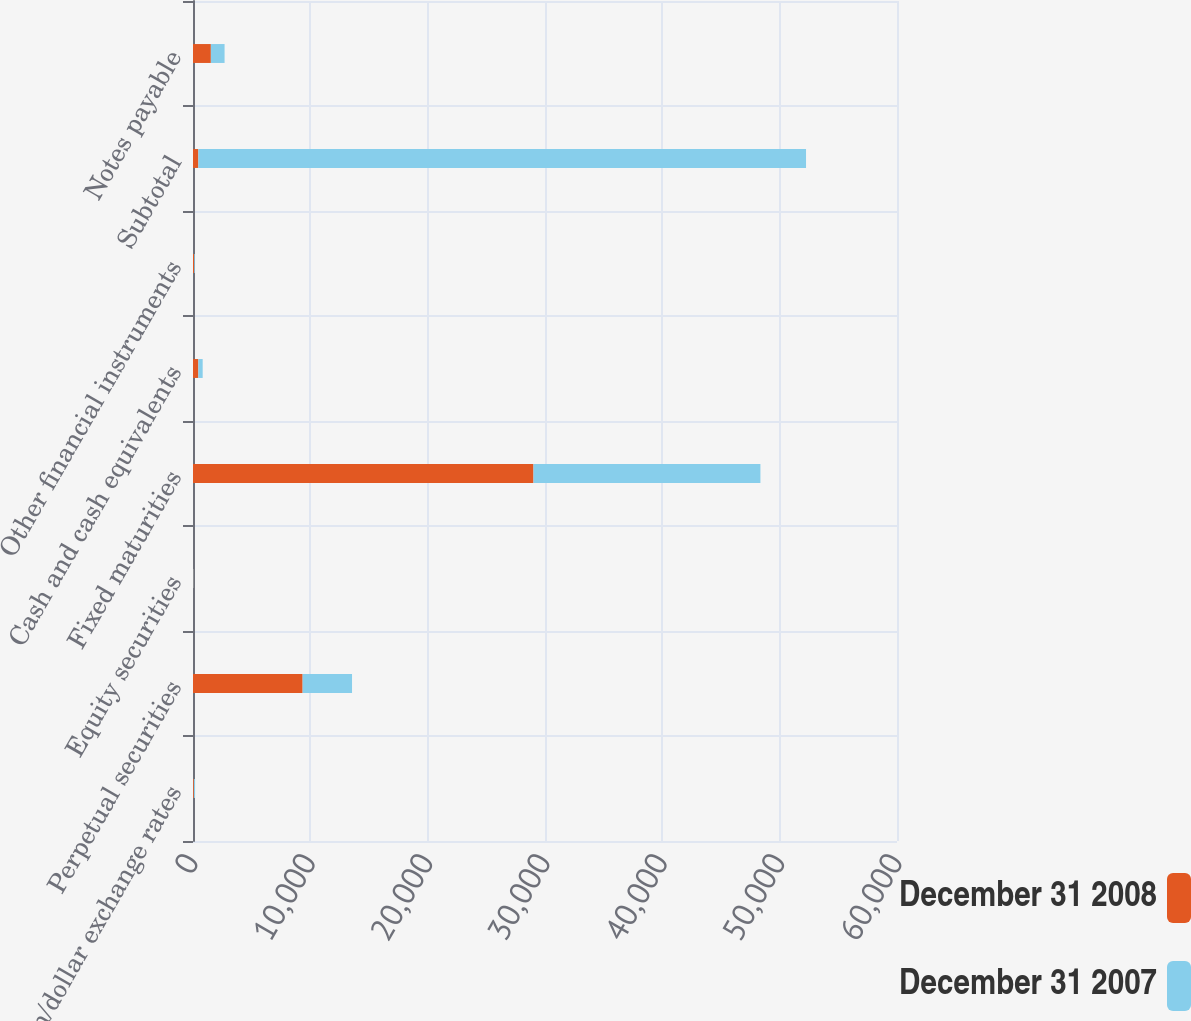Convert chart to OTSL. <chart><loc_0><loc_0><loc_500><loc_500><stacked_bar_chart><ecel><fcel>Yen/dollar exchange rates<fcel>Perpetual securities<fcel>Equity securities<fcel>Fixed maturities<fcel>Cash and cash equivalents<fcel>Other financial instruments<fcel>Subtotal<fcel>Notes payable<nl><fcel>December 31 2008<fcel>76.03<fcel>9343<fcel>26<fcel>29018<fcel>456<fcel>97<fcel>456<fcel>1522<nl><fcel>December 31 2007<fcel>99.15<fcel>4211<fcel>32<fcel>19341<fcel>369<fcel>60<fcel>51791<fcel>1169<nl></chart> 